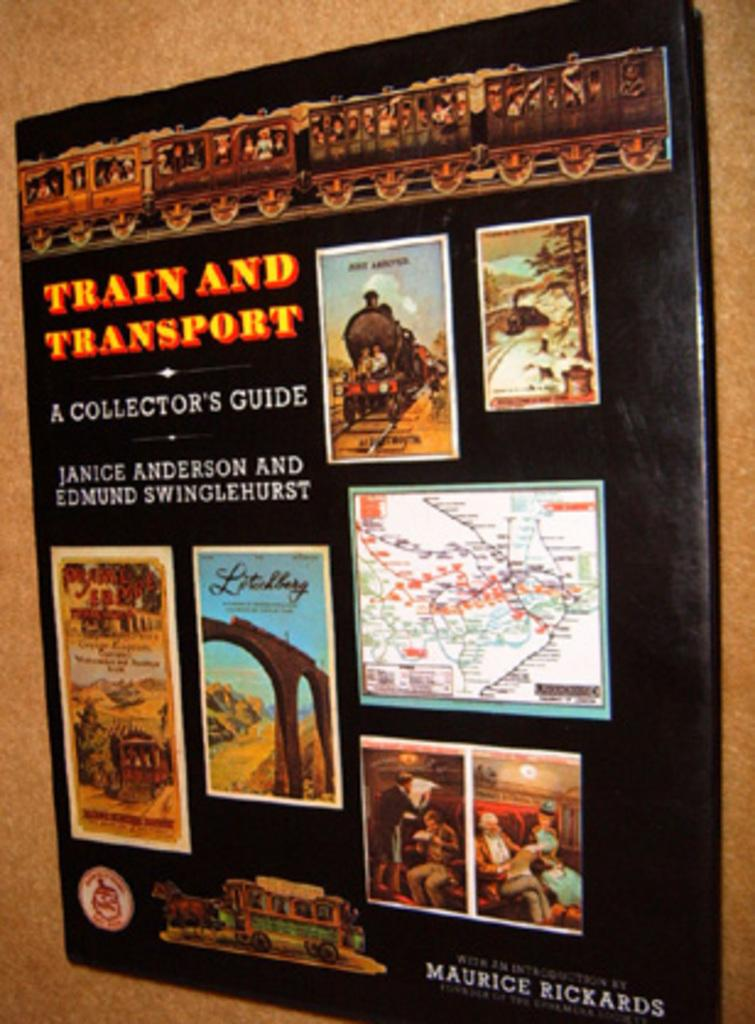Provide a one-sentence caption for the provided image. a sign giving the history of train and transport. 